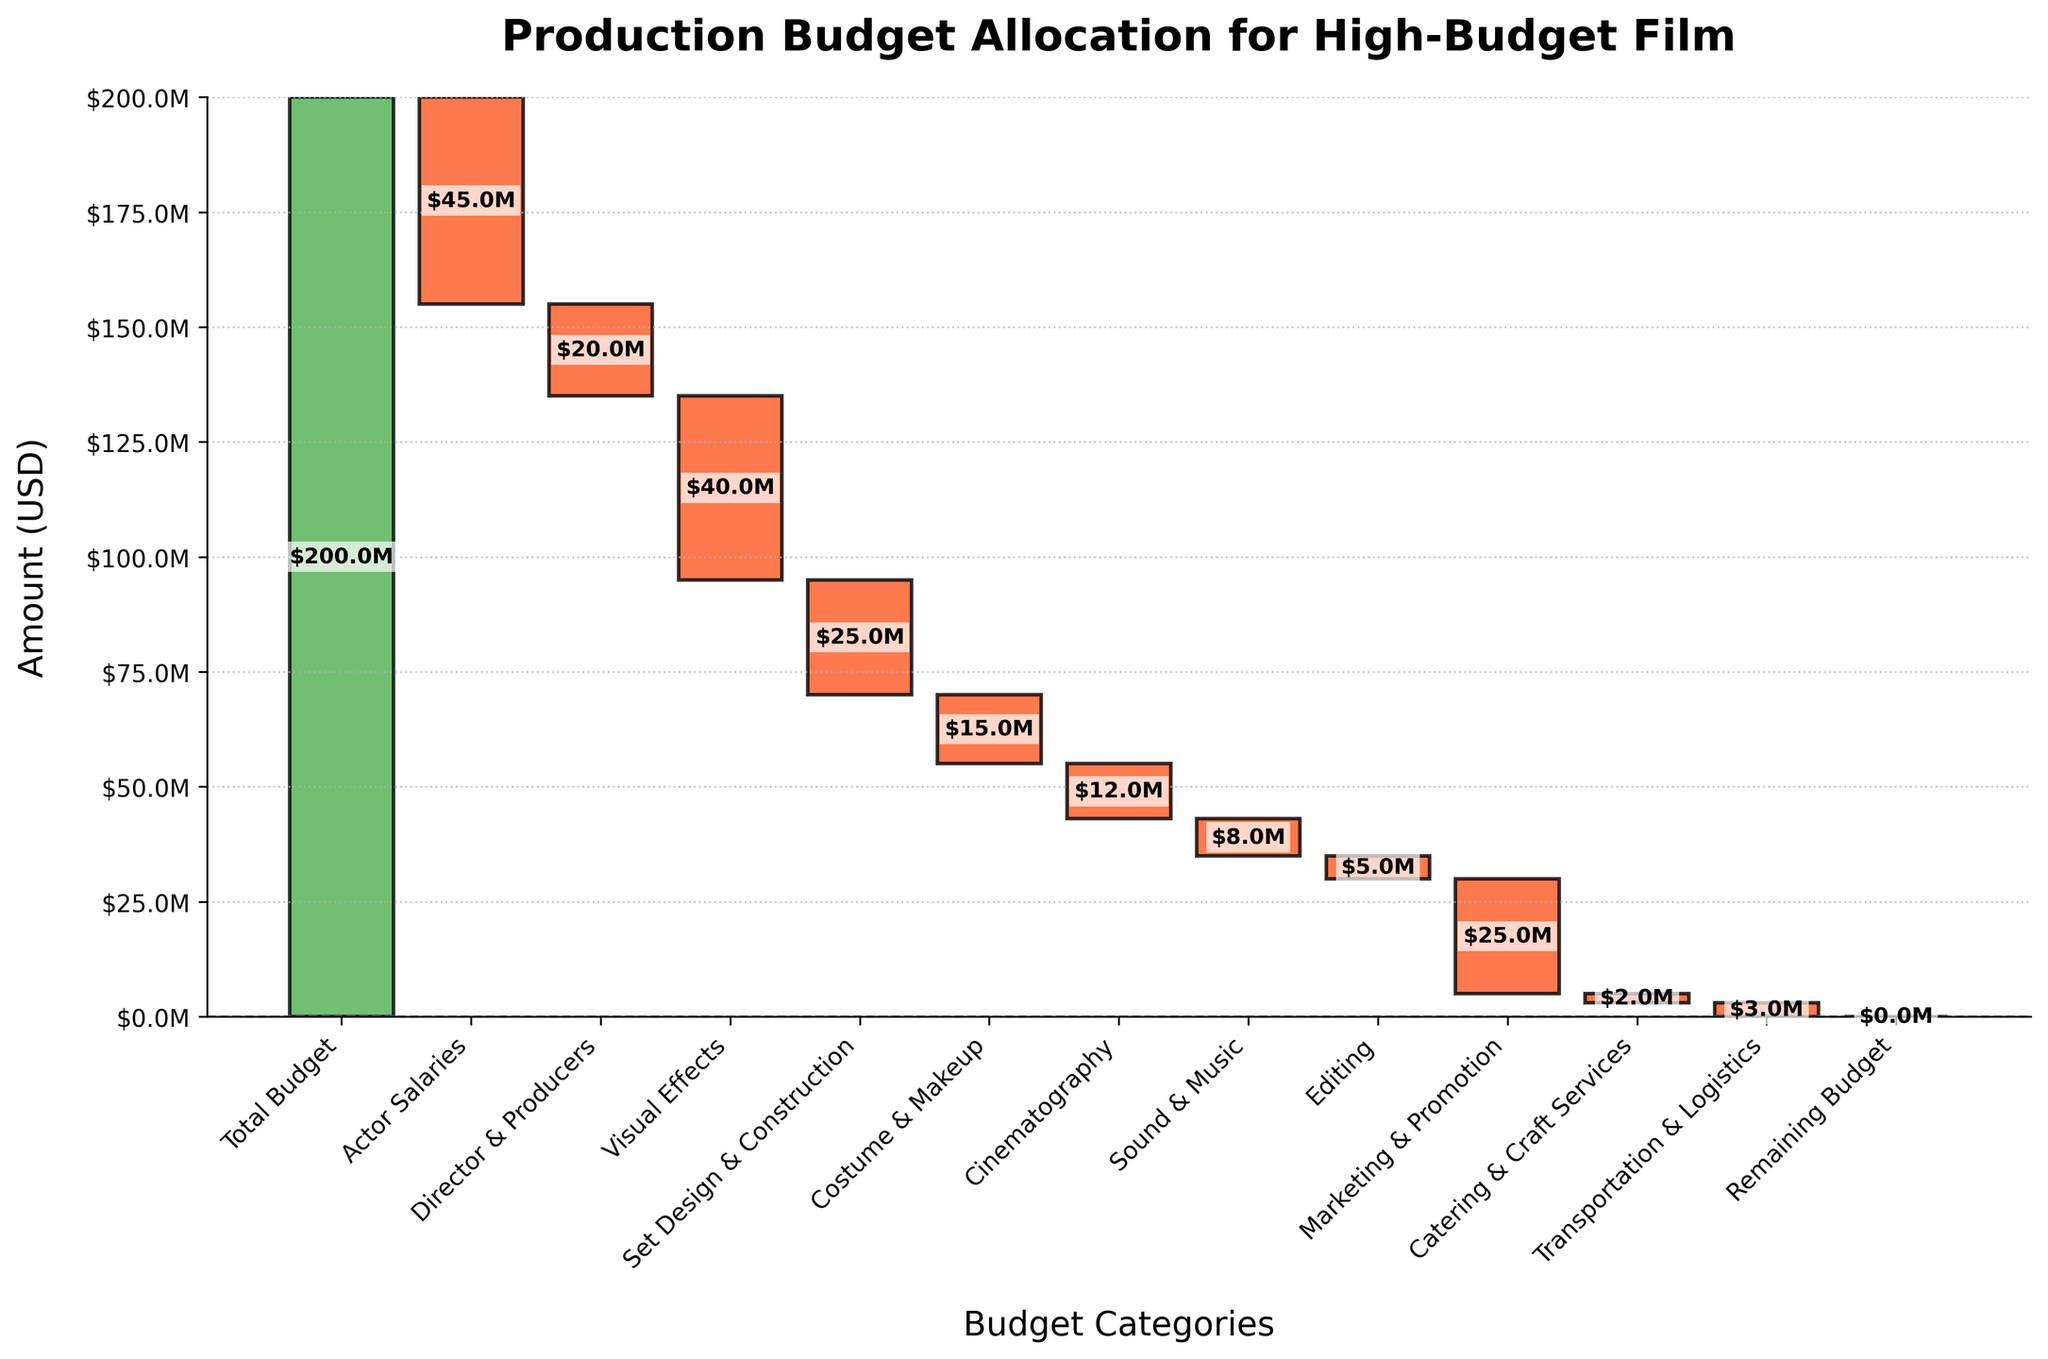Which category has the highest cost after actor salaries? The category with the highest cost after actor salaries is identified by finding the second-largest negative value in the chart. This is Visual Effects with a cost of $40M.
Answer: Visual Effects What is the total allocation for Actor Salaries and Director & Producers combined? Actor Salaries is $45M and Director & Producers is $20M. Adding these together gives 45 + 20 = $65M.
Answer: $65M Which category has the smallest expense? By looking at the smallest negative value in the chart, we see that Catering & Craft Services has the smallest expense of $2M.
Answer: Catering & Craft Services What is the amount left for Marketing & Promotion after accounting for Cinematography costs? Cinematography is $12M and we need to subtract this from the remaining amount after it. From the figure after Cinematography, we can see the remaining is $25M - $12M = $13M.
Answer: $13M How does the budget for Set Design & Construction compare to the budget for Costume & Makeup? Set Design & Construction costs $25M and Costume & Makeup costs $15M. By comparison, Set Design & Construction is higher by $10M.
Answer: $10M higher What is the total budget allocated to Cinematography, Sound & Music, Editing, and Transportation & Logistics? Cinematography: $12M, Sound & Music: $8M, Editing: $5M, and Transportation & Logistics: $3M. Adding these: 12 + 8 + 5 + 3 = $28M.
Answer: $28M What percentage of the total budget is allocated to Visual Effects? Visual Effects budget is $40M. Total budget is $200M. Percentage = (40 / 200) * 100 = 20%.
Answer: 20% How much of the budget remains after Visual Effects, Set Design & Construction, and Costume & Makeup expenses? Initial total budget is $200M. Subtract Visual Effects ($40M), Set Design & Construction ($25M), Costume & Makeup ($15M). Remaining amount: 200 - 40 - 25 - 15 = $120M.
Answer: $120M Is the budget for Director & Producers more or less than the combined budget for Editing and Transportation & Logistics? Director & Producers budget is $20M. Editing is $5M, and Transportation & Logistics is $3M, totaling 5 + 3 = $8M. The Director & Producers budget is more by $12M.
Answer: More 